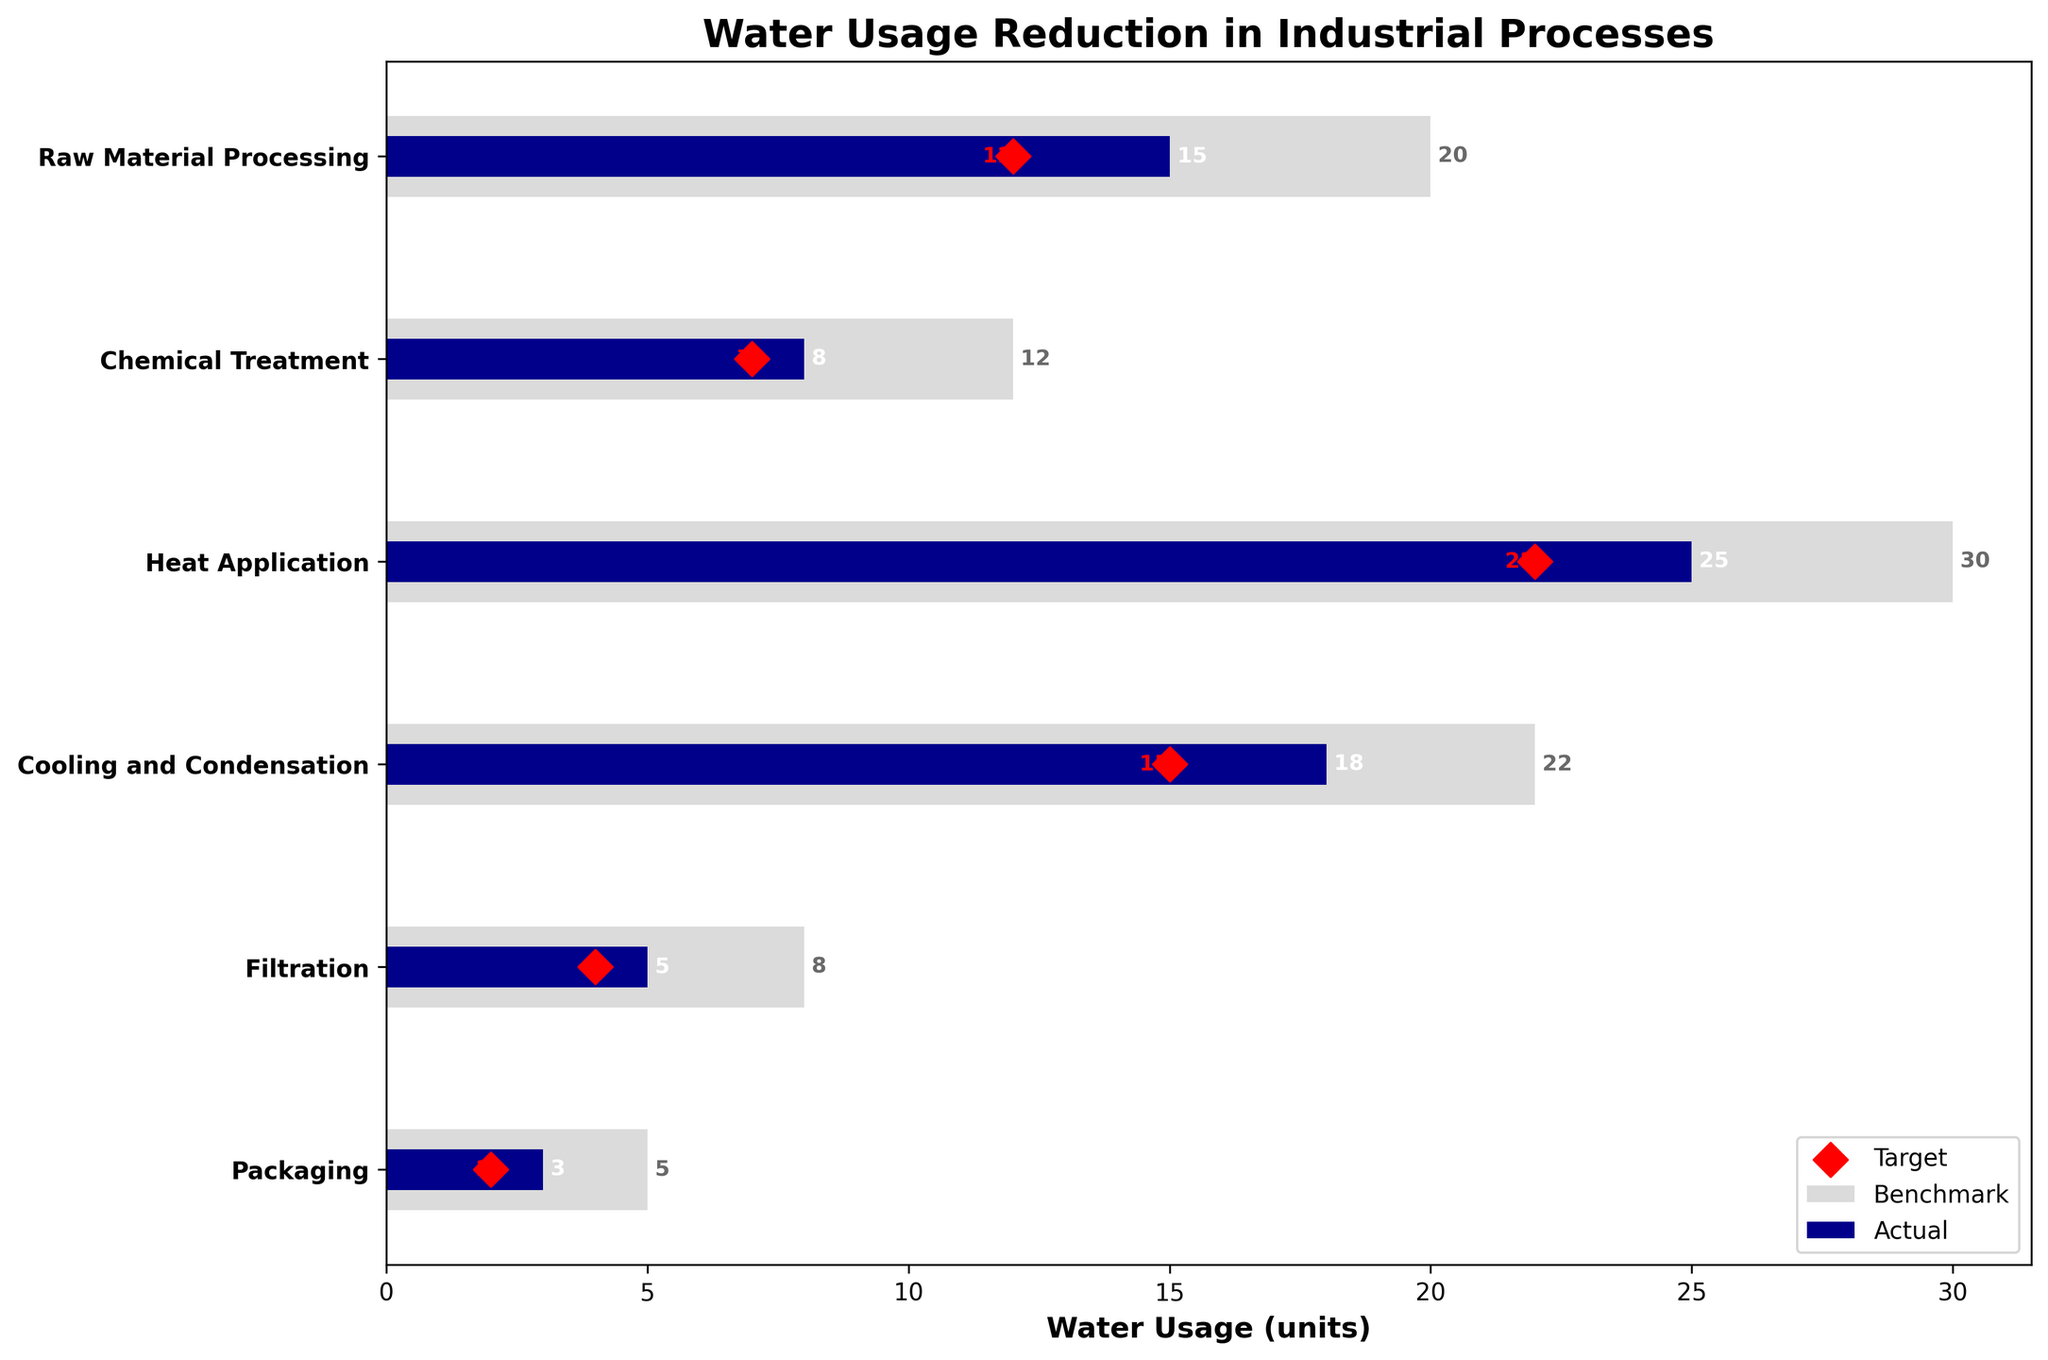What is the title of the figure? The title of the figure is prominently displayed at the top of the chart. It provides an overview of what the chart represents.
Answer: Water Usage Reduction in Industrial Processes How many production stages are depicted in the figure? By counting the number of labels on the vertical axis, each representing a different production stage, we can determine the total number.
Answer: Six What color represents the actual water usage in the figure? The actual values are depicted using a specific color for clarity and comparison against benchmarks.
Answer: Dark Blue Which production stage has the highest benchmark for water usage? Observing the lengths of the light gray bars, the longest one corresponds to the highest benchmark value. This value is associated with a specific production stage.
Answer: Heat Application What is the target value for water usage in the "Cooling and Condensation" stage? The target values are represented by red diamond markers. Locate the red marker positioned next to the "Cooling and Condensation" stage.
Answer: Fifteen Which stage shows the biggest difference between the benchmark and the actual water usage? Calculate the difference between the benchmark and actual values for each stage. The stage with the largest difference indicates the biggest reduction.
Answer: Heat Application How does the actual water usage in "Chemical Treatment" compare to its benchmark and target values? Observe the dark blue bar (actual) in relation to the light gray bar (benchmark) and red marker (target) for the "Chemical Treatment" stage.
Answer: Lower than the benchmark but slightly above the target In what stage is the target water usage closest to the actual usage? Compare the differences between each red marker (target) and corresponding dark blue bar (actual) for all stages to find the smallest gap.
Answer: Filtration What is the combined total benchmark water usage for the "Packaging" and "Filtration" stages? Sum the benchmark values (light gray bars) for both "Packaging" and "Filtration" stages.
Answer: Thirteen Are there any stages where the actual water usage exceeds the benchmark? Compare the lengths of the dark blue bars (actual) to the light gray bars (benchmark) for all stages to see if any actual values exceed their respective benchmarks.
Answer: No 